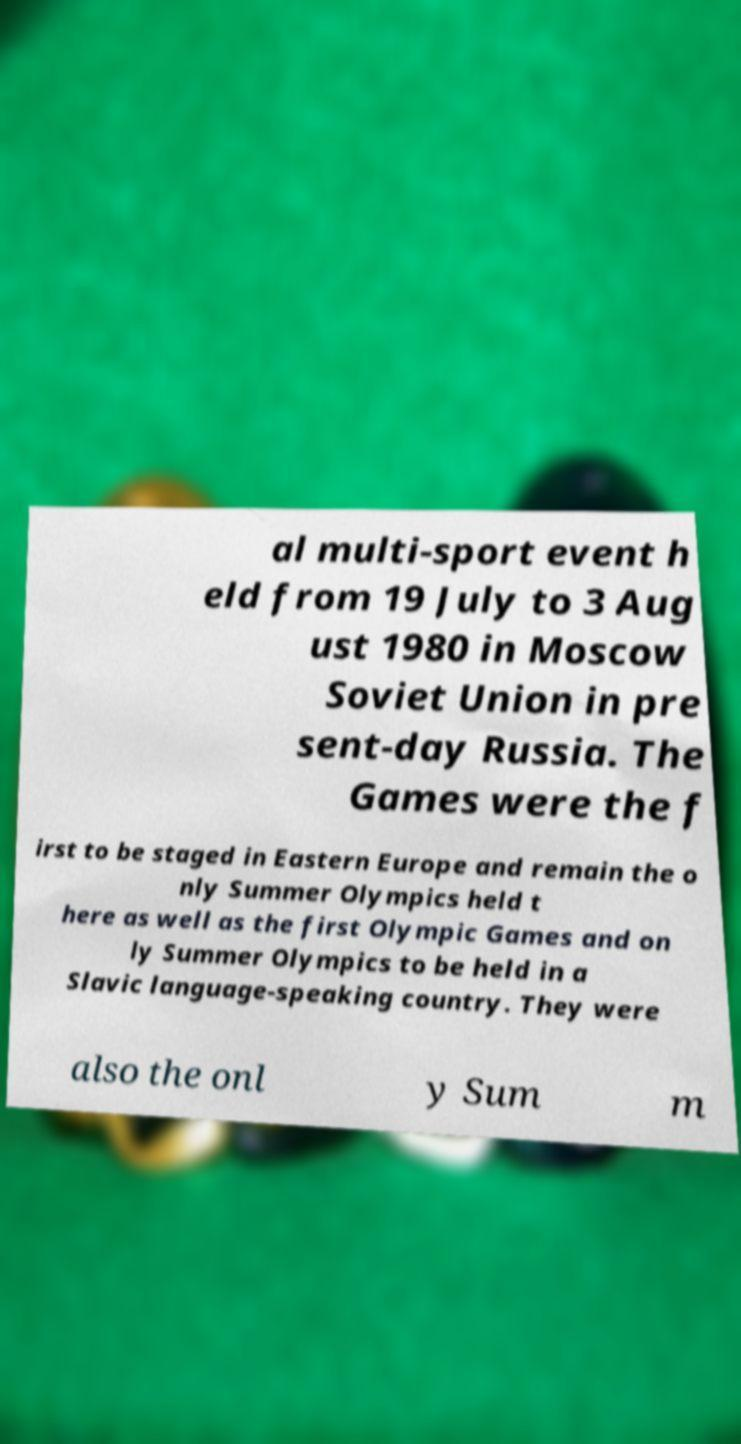Please read and relay the text visible in this image. What does it say? al multi-sport event h eld from 19 July to 3 Aug ust 1980 in Moscow Soviet Union in pre sent-day Russia. The Games were the f irst to be staged in Eastern Europe and remain the o nly Summer Olympics held t here as well as the first Olympic Games and on ly Summer Olympics to be held in a Slavic language-speaking country. They were also the onl y Sum m 